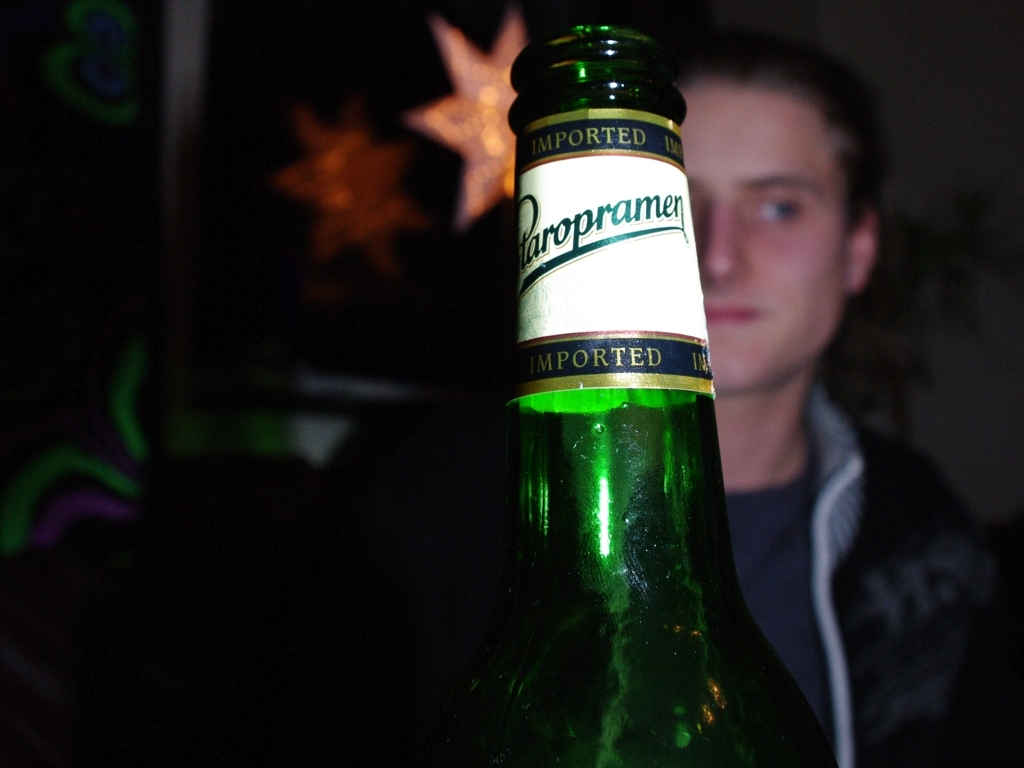How would you describe the lighting in the image? The lighting in the image is focused on the foreground, specifically on the green bottle, creating a highlighted effect while leaving the background and the person's face in soft focus and in relative shadow. This technique directs the viewer's attention to the bottle, possibly for an artistic or advertising purpose. 